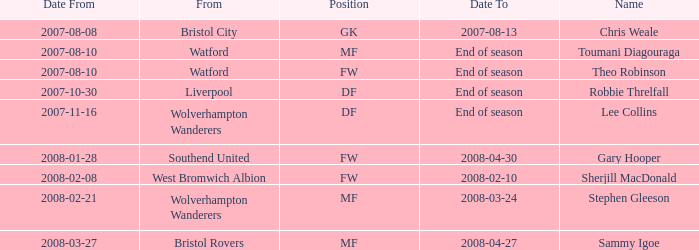What date did Toumani Diagouraga, who played position MF, start? 2007-08-10. 